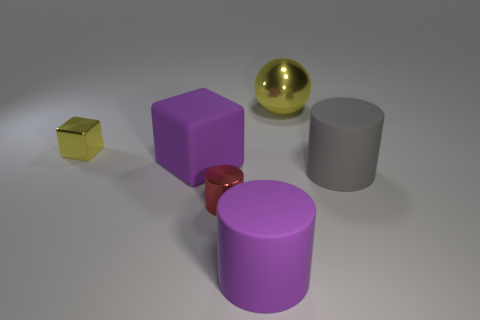Add 1 large blocks. How many objects exist? 7 Subtract all cubes. How many objects are left? 4 Subtract 0 cyan cylinders. How many objects are left? 6 Subtract all small metal cubes. Subtract all purple rubber cubes. How many objects are left? 4 Add 6 tiny shiny cylinders. How many tiny shiny cylinders are left? 7 Add 6 metallic blocks. How many metallic blocks exist? 7 